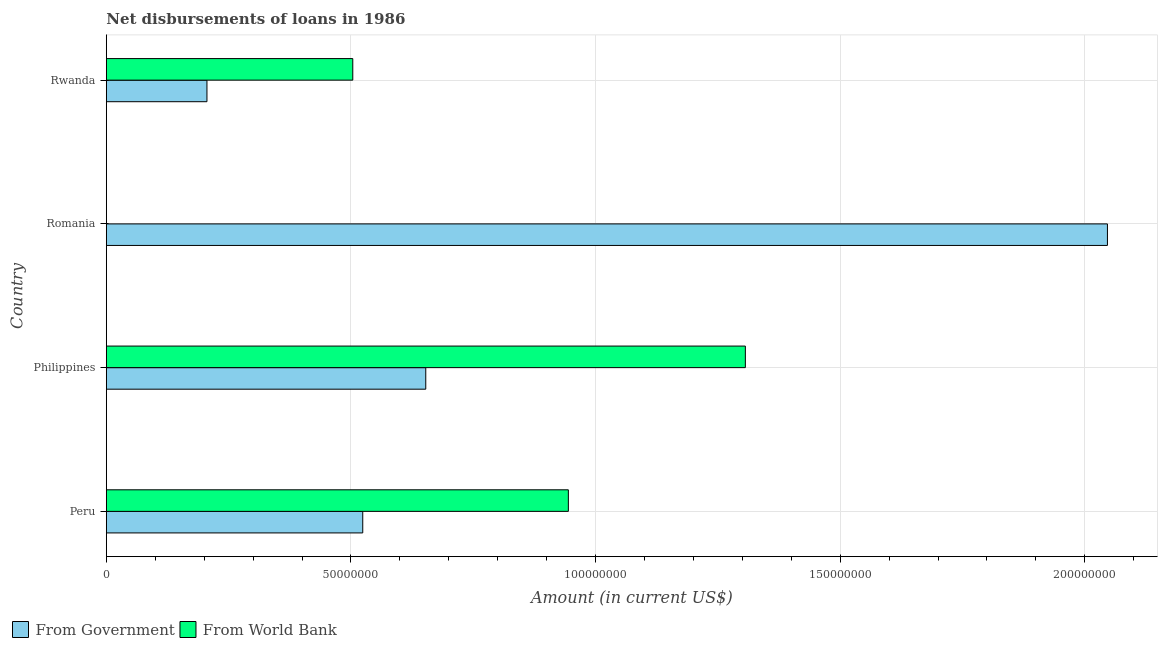How many different coloured bars are there?
Make the answer very short. 2. Are the number of bars per tick equal to the number of legend labels?
Give a very brief answer. No. How many bars are there on the 2nd tick from the top?
Offer a terse response. 1. What is the label of the 4th group of bars from the top?
Your answer should be very brief. Peru. In how many cases, is the number of bars for a given country not equal to the number of legend labels?
Offer a very short reply. 1. What is the net disbursements of loan from government in Rwanda?
Offer a terse response. 2.06e+07. Across all countries, what is the maximum net disbursements of loan from world bank?
Ensure brevity in your answer.  1.31e+08. In which country was the net disbursements of loan from government maximum?
Make the answer very short. Romania. What is the total net disbursements of loan from government in the graph?
Make the answer very short. 3.43e+08. What is the difference between the net disbursements of loan from government in Philippines and that in Rwanda?
Your answer should be very brief. 4.47e+07. What is the difference between the net disbursements of loan from world bank in Philippines and the net disbursements of loan from government in Peru?
Your answer should be very brief. 7.82e+07. What is the average net disbursements of loan from world bank per country?
Your answer should be compact. 6.89e+07. What is the difference between the net disbursements of loan from government and net disbursements of loan from world bank in Rwanda?
Offer a very short reply. -2.98e+07. In how many countries, is the net disbursements of loan from government greater than 150000000 US$?
Your answer should be compact. 1. What is the ratio of the net disbursements of loan from world bank in Peru to that in Philippines?
Ensure brevity in your answer.  0.72. What is the difference between the highest and the second highest net disbursements of loan from government?
Offer a terse response. 1.39e+08. What is the difference between the highest and the lowest net disbursements of loan from government?
Ensure brevity in your answer.  1.84e+08. How many countries are there in the graph?
Ensure brevity in your answer.  4. What is the difference between two consecutive major ticks on the X-axis?
Your response must be concise. 5.00e+07. Are the values on the major ticks of X-axis written in scientific E-notation?
Your response must be concise. No. Does the graph contain any zero values?
Make the answer very short. Yes. Where does the legend appear in the graph?
Offer a terse response. Bottom left. How many legend labels are there?
Your response must be concise. 2. How are the legend labels stacked?
Your answer should be very brief. Horizontal. What is the title of the graph?
Offer a very short reply. Net disbursements of loans in 1986. Does "Personal remittances" appear as one of the legend labels in the graph?
Offer a terse response. No. What is the label or title of the X-axis?
Your answer should be very brief. Amount (in current US$). What is the Amount (in current US$) of From Government in Peru?
Your answer should be compact. 5.24e+07. What is the Amount (in current US$) of From World Bank in Peru?
Your response must be concise. 9.44e+07. What is the Amount (in current US$) of From Government in Philippines?
Ensure brevity in your answer.  6.53e+07. What is the Amount (in current US$) of From World Bank in Philippines?
Make the answer very short. 1.31e+08. What is the Amount (in current US$) of From Government in Romania?
Ensure brevity in your answer.  2.05e+08. What is the Amount (in current US$) in From World Bank in Romania?
Offer a very short reply. 0. What is the Amount (in current US$) of From Government in Rwanda?
Ensure brevity in your answer.  2.06e+07. What is the Amount (in current US$) in From World Bank in Rwanda?
Keep it short and to the point. 5.04e+07. Across all countries, what is the maximum Amount (in current US$) in From Government?
Keep it short and to the point. 2.05e+08. Across all countries, what is the maximum Amount (in current US$) of From World Bank?
Provide a succinct answer. 1.31e+08. Across all countries, what is the minimum Amount (in current US$) in From Government?
Your answer should be very brief. 2.06e+07. What is the total Amount (in current US$) in From Government in the graph?
Give a very brief answer. 3.43e+08. What is the total Amount (in current US$) of From World Bank in the graph?
Offer a very short reply. 2.75e+08. What is the difference between the Amount (in current US$) in From Government in Peru and that in Philippines?
Offer a terse response. -1.29e+07. What is the difference between the Amount (in current US$) of From World Bank in Peru and that in Philippines?
Ensure brevity in your answer.  -3.62e+07. What is the difference between the Amount (in current US$) in From Government in Peru and that in Romania?
Your response must be concise. -1.52e+08. What is the difference between the Amount (in current US$) of From Government in Peru and that in Rwanda?
Provide a short and direct response. 3.18e+07. What is the difference between the Amount (in current US$) of From World Bank in Peru and that in Rwanda?
Provide a short and direct response. 4.41e+07. What is the difference between the Amount (in current US$) of From Government in Philippines and that in Romania?
Ensure brevity in your answer.  -1.39e+08. What is the difference between the Amount (in current US$) in From Government in Philippines and that in Rwanda?
Ensure brevity in your answer.  4.47e+07. What is the difference between the Amount (in current US$) in From World Bank in Philippines and that in Rwanda?
Your response must be concise. 8.02e+07. What is the difference between the Amount (in current US$) of From Government in Romania and that in Rwanda?
Provide a succinct answer. 1.84e+08. What is the difference between the Amount (in current US$) in From Government in Peru and the Amount (in current US$) in From World Bank in Philippines?
Your answer should be very brief. -7.82e+07. What is the difference between the Amount (in current US$) of From Government in Peru and the Amount (in current US$) of From World Bank in Rwanda?
Provide a short and direct response. 2.04e+06. What is the difference between the Amount (in current US$) in From Government in Philippines and the Amount (in current US$) in From World Bank in Rwanda?
Your answer should be compact. 1.49e+07. What is the difference between the Amount (in current US$) in From Government in Romania and the Amount (in current US$) in From World Bank in Rwanda?
Make the answer very short. 1.54e+08. What is the average Amount (in current US$) in From Government per country?
Your answer should be compact. 8.57e+07. What is the average Amount (in current US$) in From World Bank per country?
Offer a terse response. 6.89e+07. What is the difference between the Amount (in current US$) in From Government and Amount (in current US$) in From World Bank in Peru?
Provide a short and direct response. -4.20e+07. What is the difference between the Amount (in current US$) of From Government and Amount (in current US$) of From World Bank in Philippines?
Provide a succinct answer. -6.53e+07. What is the difference between the Amount (in current US$) in From Government and Amount (in current US$) in From World Bank in Rwanda?
Make the answer very short. -2.98e+07. What is the ratio of the Amount (in current US$) in From Government in Peru to that in Philippines?
Ensure brevity in your answer.  0.8. What is the ratio of the Amount (in current US$) of From World Bank in Peru to that in Philippines?
Offer a terse response. 0.72. What is the ratio of the Amount (in current US$) of From Government in Peru to that in Romania?
Offer a terse response. 0.26. What is the ratio of the Amount (in current US$) of From Government in Peru to that in Rwanda?
Offer a very short reply. 2.55. What is the ratio of the Amount (in current US$) in From World Bank in Peru to that in Rwanda?
Offer a very short reply. 1.87. What is the ratio of the Amount (in current US$) in From Government in Philippines to that in Romania?
Offer a very short reply. 0.32. What is the ratio of the Amount (in current US$) in From Government in Philippines to that in Rwanda?
Keep it short and to the point. 3.17. What is the ratio of the Amount (in current US$) in From World Bank in Philippines to that in Rwanda?
Your answer should be very brief. 2.59. What is the ratio of the Amount (in current US$) of From Government in Romania to that in Rwanda?
Make the answer very short. 9.95. What is the difference between the highest and the second highest Amount (in current US$) in From Government?
Your answer should be very brief. 1.39e+08. What is the difference between the highest and the second highest Amount (in current US$) of From World Bank?
Offer a terse response. 3.62e+07. What is the difference between the highest and the lowest Amount (in current US$) of From Government?
Keep it short and to the point. 1.84e+08. What is the difference between the highest and the lowest Amount (in current US$) in From World Bank?
Provide a short and direct response. 1.31e+08. 